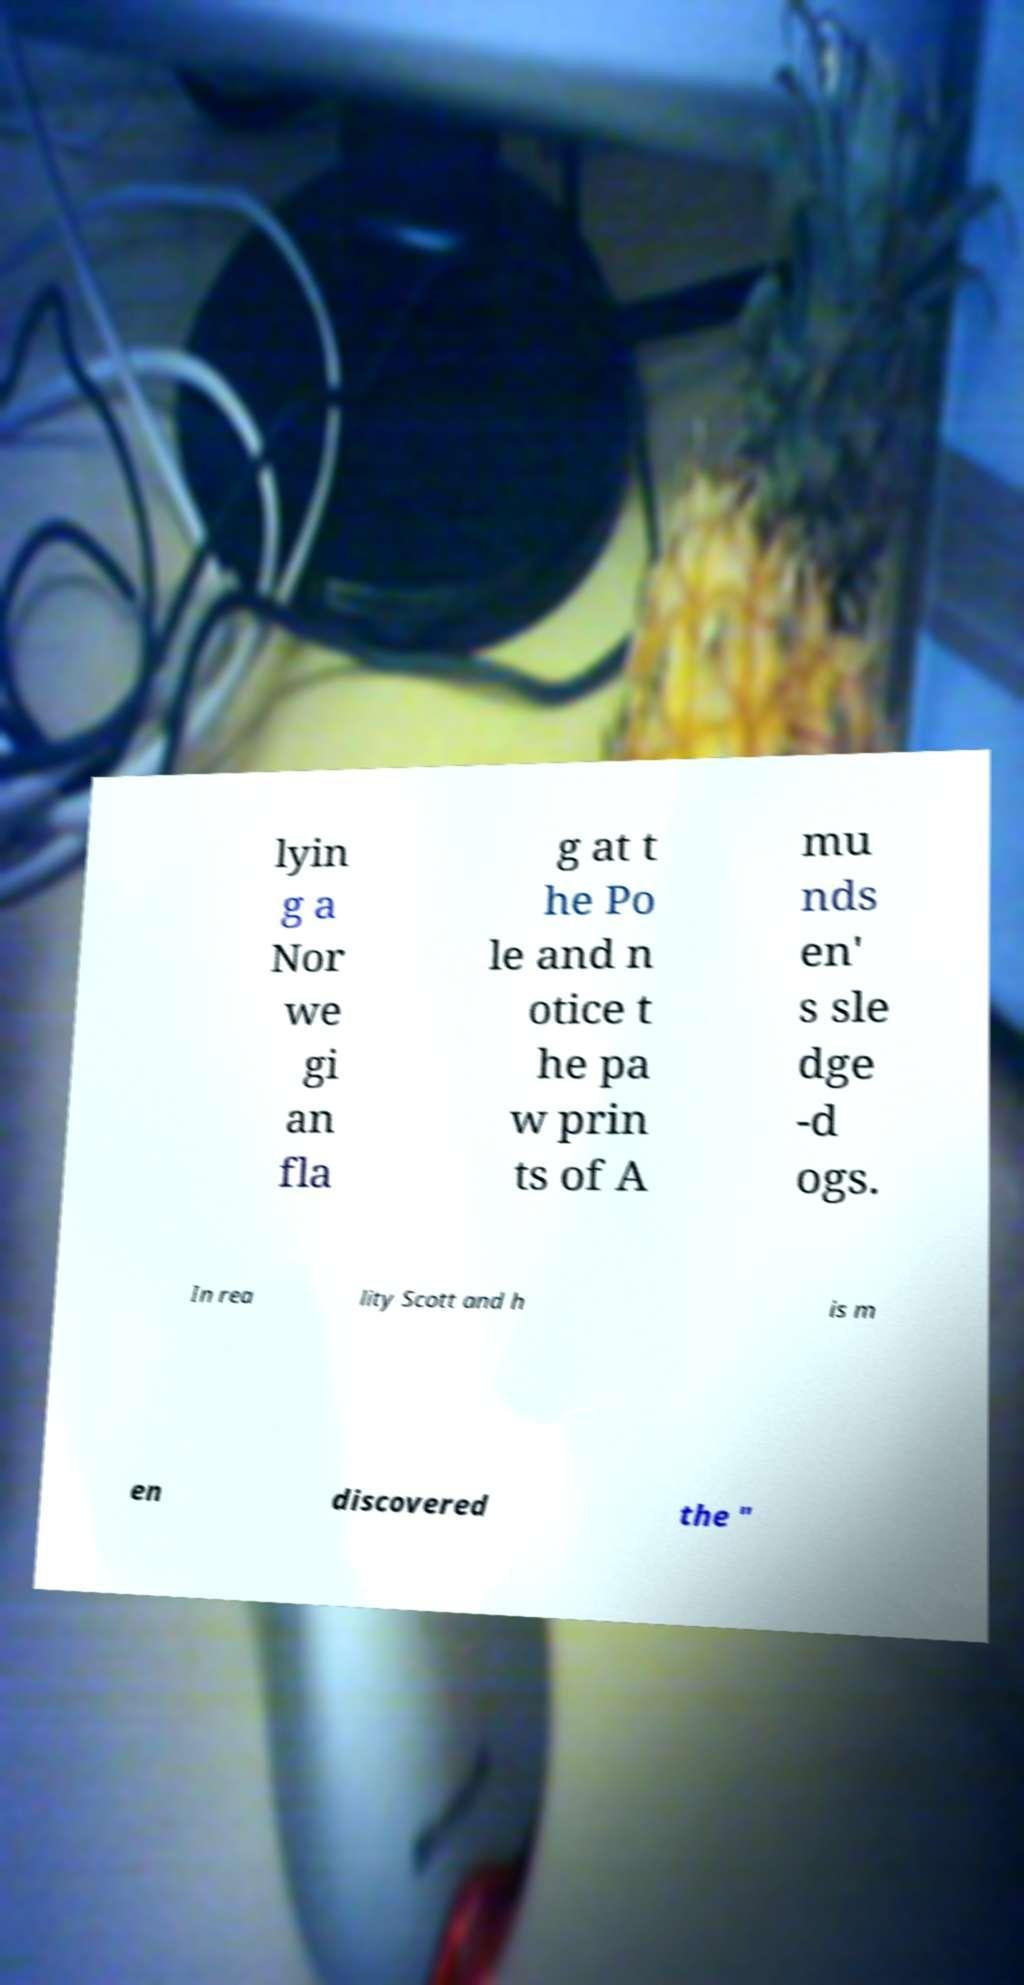What messages or text are displayed in this image? I need them in a readable, typed format. lyin g a Nor we gi an fla g at t he Po le and n otice t he pa w prin ts of A mu nds en' s sle dge -d ogs. In rea lity Scott and h is m en discovered the " 